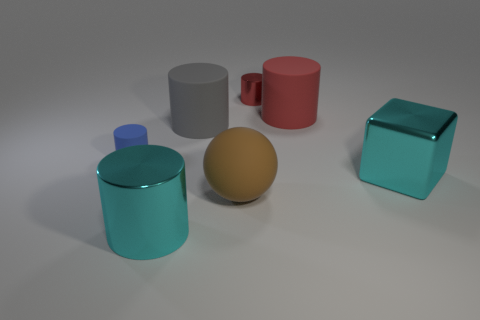Add 2 yellow metal objects. How many objects exist? 9 Subtract all large cyan metallic cylinders. How many cylinders are left? 4 Subtract all red cylinders. How many cylinders are left? 3 Subtract all balls. How many objects are left? 6 Subtract 1 blocks. How many blocks are left? 0 Subtract all gray cylinders. Subtract all cyan balls. How many cylinders are left? 4 Subtract all red cubes. How many cyan cylinders are left? 1 Subtract all big cyan rubber cylinders. Subtract all matte balls. How many objects are left? 6 Add 7 large metal cylinders. How many large metal cylinders are left? 8 Add 5 big objects. How many big objects exist? 10 